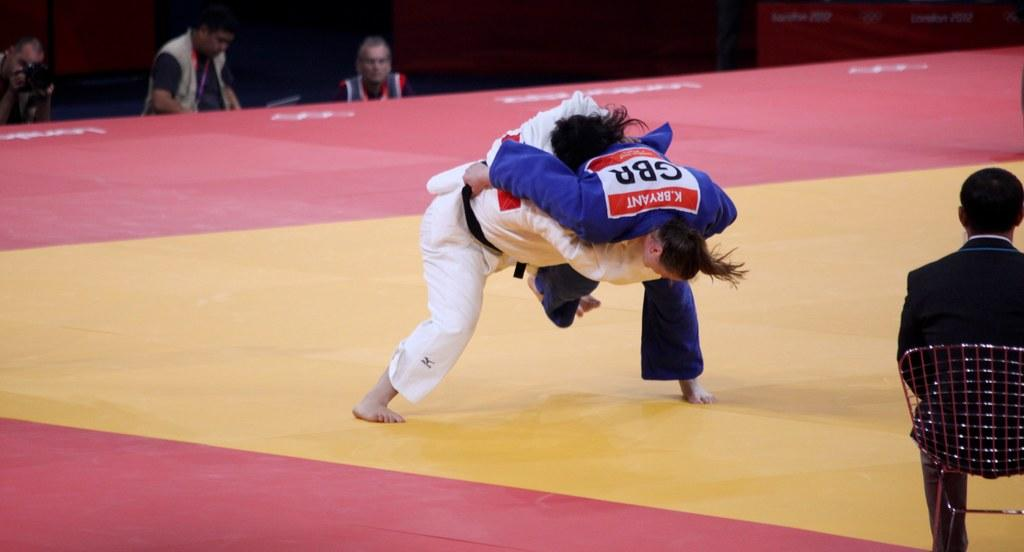<image>
Offer a succinct explanation of the picture presented. Two guys wrestling on a mat one with the letters GBA on the back and with someone in a chair sitting and watching. 